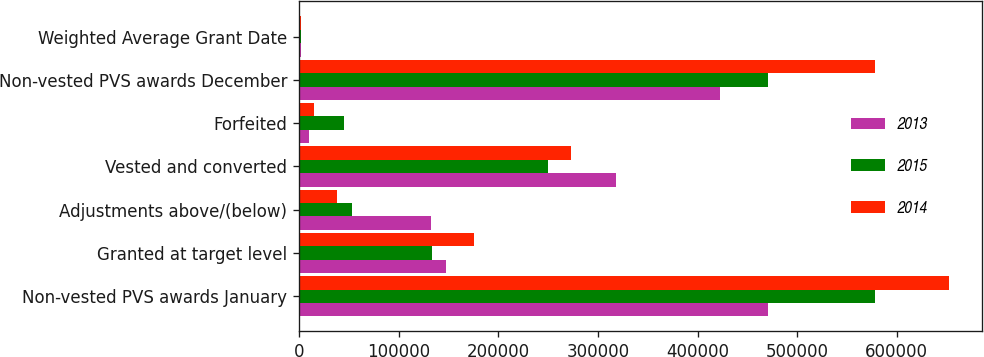<chart> <loc_0><loc_0><loc_500><loc_500><stacked_bar_chart><ecel><fcel>Non-vested PVS awards January<fcel>Granted at target level<fcel>Adjustments above/(below)<fcel>Vested and converted<fcel>Forfeited<fcel>Non-vested PVS awards December<fcel>Weighted Average Grant Date<nl><fcel>2013<fcel>470719<fcel>147908<fcel>132444<fcel>318337<fcel>10008<fcel>422726<fcel>2015<nl><fcel>2015<fcel>578358<fcel>133823<fcel>53438<fcel>250205<fcel>44695<fcel>470719<fcel>2014<nl><fcel>2014<fcel>652662<fcel>175498<fcel>38330<fcel>273044<fcel>15088<fcel>578358<fcel>2013<nl></chart> 